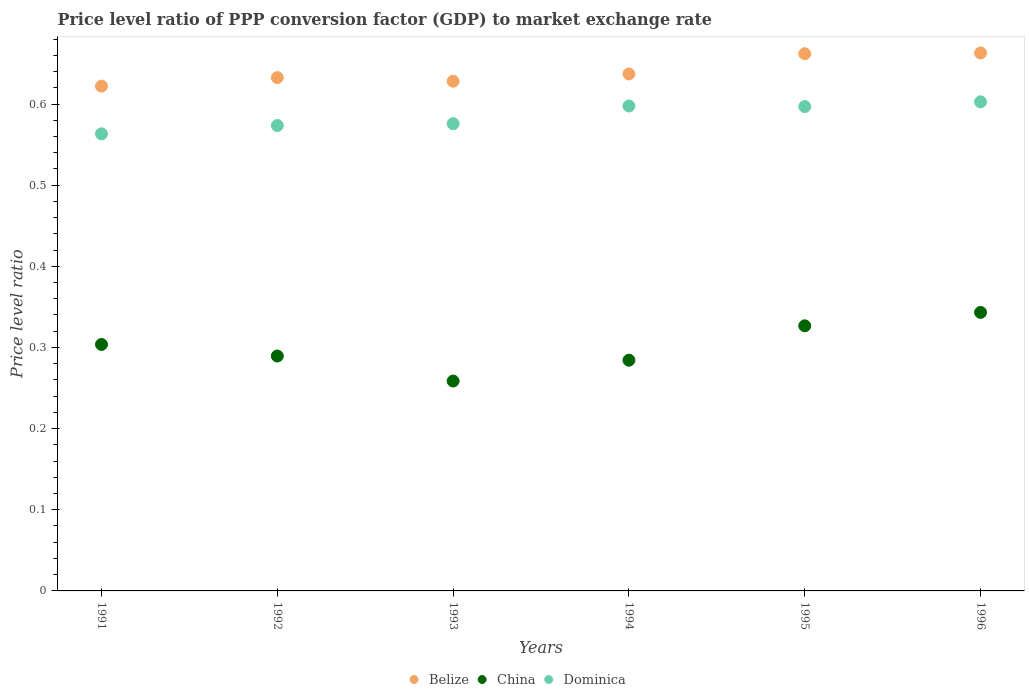How many different coloured dotlines are there?
Your response must be concise. 3. Is the number of dotlines equal to the number of legend labels?
Offer a terse response. Yes. What is the price level ratio in Belize in 1991?
Make the answer very short. 0.62. Across all years, what is the maximum price level ratio in Belize?
Make the answer very short. 0.66. Across all years, what is the minimum price level ratio in China?
Offer a terse response. 0.26. In which year was the price level ratio in Dominica maximum?
Give a very brief answer. 1996. What is the total price level ratio in Dominica in the graph?
Offer a very short reply. 3.51. What is the difference between the price level ratio in China in 1992 and that in 1993?
Keep it short and to the point. 0.03. What is the difference between the price level ratio in China in 1995 and the price level ratio in Dominica in 1996?
Offer a very short reply. -0.28. What is the average price level ratio in China per year?
Ensure brevity in your answer.  0.3. In the year 1992, what is the difference between the price level ratio in Belize and price level ratio in China?
Your answer should be compact. 0.34. What is the ratio of the price level ratio in China in 1991 to that in 1993?
Give a very brief answer. 1.17. Is the price level ratio in Dominica in 1991 less than that in 1994?
Make the answer very short. Yes. Is the difference between the price level ratio in Belize in 1991 and 1992 greater than the difference between the price level ratio in China in 1991 and 1992?
Your answer should be compact. No. What is the difference between the highest and the second highest price level ratio in China?
Ensure brevity in your answer.  0.02. What is the difference between the highest and the lowest price level ratio in Dominica?
Keep it short and to the point. 0.04. In how many years, is the price level ratio in China greater than the average price level ratio in China taken over all years?
Your response must be concise. 3. Is the sum of the price level ratio in Belize in 1991 and 1996 greater than the maximum price level ratio in China across all years?
Make the answer very short. Yes. Does the price level ratio in Belize monotonically increase over the years?
Keep it short and to the point. No. Is the price level ratio in Belize strictly greater than the price level ratio in Dominica over the years?
Provide a succinct answer. Yes. What is the difference between two consecutive major ticks on the Y-axis?
Your answer should be very brief. 0.1. Are the values on the major ticks of Y-axis written in scientific E-notation?
Keep it short and to the point. No. How many legend labels are there?
Your response must be concise. 3. What is the title of the graph?
Your answer should be compact. Price level ratio of PPP conversion factor (GDP) to market exchange rate. What is the label or title of the X-axis?
Keep it short and to the point. Years. What is the label or title of the Y-axis?
Provide a succinct answer. Price level ratio. What is the Price level ratio of Belize in 1991?
Your answer should be compact. 0.62. What is the Price level ratio in China in 1991?
Offer a terse response. 0.3. What is the Price level ratio of Dominica in 1991?
Give a very brief answer. 0.56. What is the Price level ratio of Belize in 1992?
Your response must be concise. 0.63. What is the Price level ratio in China in 1992?
Your answer should be very brief. 0.29. What is the Price level ratio in Dominica in 1992?
Provide a short and direct response. 0.57. What is the Price level ratio in Belize in 1993?
Ensure brevity in your answer.  0.63. What is the Price level ratio of China in 1993?
Your answer should be compact. 0.26. What is the Price level ratio of Dominica in 1993?
Give a very brief answer. 0.58. What is the Price level ratio in Belize in 1994?
Offer a very short reply. 0.64. What is the Price level ratio of China in 1994?
Keep it short and to the point. 0.28. What is the Price level ratio in Dominica in 1994?
Your answer should be compact. 0.6. What is the Price level ratio in Belize in 1995?
Offer a terse response. 0.66. What is the Price level ratio in China in 1995?
Provide a short and direct response. 0.33. What is the Price level ratio in Dominica in 1995?
Offer a very short reply. 0.6. What is the Price level ratio in Belize in 1996?
Offer a very short reply. 0.66. What is the Price level ratio in China in 1996?
Offer a very short reply. 0.34. What is the Price level ratio of Dominica in 1996?
Make the answer very short. 0.6. Across all years, what is the maximum Price level ratio in Belize?
Ensure brevity in your answer.  0.66. Across all years, what is the maximum Price level ratio of China?
Offer a very short reply. 0.34. Across all years, what is the maximum Price level ratio of Dominica?
Your response must be concise. 0.6. Across all years, what is the minimum Price level ratio of Belize?
Offer a very short reply. 0.62. Across all years, what is the minimum Price level ratio of China?
Provide a succinct answer. 0.26. Across all years, what is the minimum Price level ratio of Dominica?
Provide a succinct answer. 0.56. What is the total Price level ratio of Belize in the graph?
Give a very brief answer. 3.84. What is the total Price level ratio in China in the graph?
Provide a short and direct response. 1.81. What is the total Price level ratio in Dominica in the graph?
Your answer should be compact. 3.51. What is the difference between the Price level ratio of Belize in 1991 and that in 1992?
Keep it short and to the point. -0.01. What is the difference between the Price level ratio in China in 1991 and that in 1992?
Keep it short and to the point. 0.01. What is the difference between the Price level ratio in Dominica in 1991 and that in 1992?
Provide a short and direct response. -0.01. What is the difference between the Price level ratio of Belize in 1991 and that in 1993?
Provide a short and direct response. -0.01. What is the difference between the Price level ratio in China in 1991 and that in 1993?
Make the answer very short. 0.05. What is the difference between the Price level ratio in Dominica in 1991 and that in 1993?
Your response must be concise. -0.01. What is the difference between the Price level ratio in Belize in 1991 and that in 1994?
Offer a very short reply. -0.01. What is the difference between the Price level ratio in China in 1991 and that in 1994?
Provide a succinct answer. 0.02. What is the difference between the Price level ratio of Dominica in 1991 and that in 1994?
Your answer should be very brief. -0.03. What is the difference between the Price level ratio in Belize in 1991 and that in 1995?
Make the answer very short. -0.04. What is the difference between the Price level ratio of China in 1991 and that in 1995?
Keep it short and to the point. -0.02. What is the difference between the Price level ratio in Dominica in 1991 and that in 1995?
Ensure brevity in your answer.  -0.03. What is the difference between the Price level ratio of Belize in 1991 and that in 1996?
Provide a succinct answer. -0.04. What is the difference between the Price level ratio in China in 1991 and that in 1996?
Your answer should be compact. -0.04. What is the difference between the Price level ratio of Dominica in 1991 and that in 1996?
Your answer should be very brief. -0.04. What is the difference between the Price level ratio of Belize in 1992 and that in 1993?
Give a very brief answer. 0. What is the difference between the Price level ratio of China in 1992 and that in 1993?
Your response must be concise. 0.03. What is the difference between the Price level ratio in Dominica in 1992 and that in 1993?
Your response must be concise. -0. What is the difference between the Price level ratio in Belize in 1992 and that in 1994?
Provide a succinct answer. -0. What is the difference between the Price level ratio in China in 1992 and that in 1994?
Give a very brief answer. 0.01. What is the difference between the Price level ratio of Dominica in 1992 and that in 1994?
Provide a short and direct response. -0.02. What is the difference between the Price level ratio in Belize in 1992 and that in 1995?
Give a very brief answer. -0.03. What is the difference between the Price level ratio of China in 1992 and that in 1995?
Your response must be concise. -0.04. What is the difference between the Price level ratio of Dominica in 1992 and that in 1995?
Your answer should be very brief. -0.02. What is the difference between the Price level ratio of Belize in 1992 and that in 1996?
Your answer should be compact. -0.03. What is the difference between the Price level ratio of China in 1992 and that in 1996?
Keep it short and to the point. -0.05. What is the difference between the Price level ratio of Dominica in 1992 and that in 1996?
Your answer should be very brief. -0.03. What is the difference between the Price level ratio in Belize in 1993 and that in 1994?
Ensure brevity in your answer.  -0.01. What is the difference between the Price level ratio of China in 1993 and that in 1994?
Offer a very short reply. -0.03. What is the difference between the Price level ratio of Dominica in 1993 and that in 1994?
Your answer should be very brief. -0.02. What is the difference between the Price level ratio in Belize in 1993 and that in 1995?
Your answer should be compact. -0.03. What is the difference between the Price level ratio of China in 1993 and that in 1995?
Offer a very short reply. -0.07. What is the difference between the Price level ratio in Dominica in 1993 and that in 1995?
Your response must be concise. -0.02. What is the difference between the Price level ratio of Belize in 1993 and that in 1996?
Ensure brevity in your answer.  -0.03. What is the difference between the Price level ratio in China in 1993 and that in 1996?
Offer a terse response. -0.08. What is the difference between the Price level ratio in Dominica in 1993 and that in 1996?
Provide a short and direct response. -0.03. What is the difference between the Price level ratio in Belize in 1994 and that in 1995?
Offer a very short reply. -0.02. What is the difference between the Price level ratio of China in 1994 and that in 1995?
Your answer should be very brief. -0.04. What is the difference between the Price level ratio of Dominica in 1994 and that in 1995?
Your answer should be very brief. 0. What is the difference between the Price level ratio of Belize in 1994 and that in 1996?
Keep it short and to the point. -0.03. What is the difference between the Price level ratio in China in 1994 and that in 1996?
Offer a very short reply. -0.06. What is the difference between the Price level ratio of Dominica in 1994 and that in 1996?
Your answer should be very brief. -0.01. What is the difference between the Price level ratio in Belize in 1995 and that in 1996?
Make the answer very short. -0. What is the difference between the Price level ratio in China in 1995 and that in 1996?
Offer a very short reply. -0.02. What is the difference between the Price level ratio of Dominica in 1995 and that in 1996?
Make the answer very short. -0.01. What is the difference between the Price level ratio of Belize in 1991 and the Price level ratio of China in 1992?
Give a very brief answer. 0.33. What is the difference between the Price level ratio of Belize in 1991 and the Price level ratio of Dominica in 1992?
Your answer should be very brief. 0.05. What is the difference between the Price level ratio of China in 1991 and the Price level ratio of Dominica in 1992?
Your answer should be compact. -0.27. What is the difference between the Price level ratio in Belize in 1991 and the Price level ratio in China in 1993?
Make the answer very short. 0.36. What is the difference between the Price level ratio of Belize in 1991 and the Price level ratio of Dominica in 1993?
Your answer should be very brief. 0.05. What is the difference between the Price level ratio in China in 1991 and the Price level ratio in Dominica in 1993?
Offer a very short reply. -0.27. What is the difference between the Price level ratio in Belize in 1991 and the Price level ratio in China in 1994?
Offer a very short reply. 0.34. What is the difference between the Price level ratio of Belize in 1991 and the Price level ratio of Dominica in 1994?
Provide a succinct answer. 0.02. What is the difference between the Price level ratio in China in 1991 and the Price level ratio in Dominica in 1994?
Provide a short and direct response. -0.29. What is the difference between the Price level ratio in Belize in 1991 and the Price level ratio in China in 1995?
Offer a very short reply. 0.3. What is the difference between the Price level ratio of Belize in 1991 and the Price level ratio of Dominica in 1995?
Your answer should be very brief. 0.03. What is the difference between the Price level ratio in China in 1991 and the Price level ratio in Dominica in 1995?
Your response must be concise. -0.29. What is the difference between the Price level ratio of Belize in 1991 and the Price level ratio of China in 1996?
Offer a very short reply. 0.28. What is the difference between the Price level ratio of Belize in 1991 and the Price level ratio of Dominica in 1996?
Offer a very short reply. 0.02. What is the difference between the Price level ratio of China in 1991 and the Price level ratio of Dominica in 1996?
Your answer should be compact. -0.3. What is the difference between the Price level ratio in Belize in 1992 and the Price level ratio in China in 1993?
Offer a very short reply. 0.37. What is the difference between the Price level ratio in Belize in 1992 and the Price level ratio in Dominica in 1993?
Keep it short and to the point. 0.06. What is the difference between the Price level ratio of China in 1992 and the Price level ratio of Dominica in 1993?
Provide a succinct answer. -0.29. What is the difference between the Price level ratio in Belize in 1992 and the Price level ratio in China in 1994?
Offer a terse response. 0.35. What is the difference between the Price level ratio of Belize in 1992 and the Price level ratio of Dominica in 1994?
Offer a very short reply. 0.04. What is the difference between the Price level ratio in China in 1992 and the Price level ratio in Dominica in 1994?
Give a very brief answer. -0.31. What is the difference between the Price level ratio of Belize in 1992 and the Price level ratio of China in 1995?
Give a very brief answer. 0.31. What is the difference between the Price level ratio in Belize in 1992 and the Price level ratio in Dominica in 1995?
Keep it short and to the point. 0.04. What is the difference between the Price level ratio of China in 1992 and the Price level ratio of Dominica in 1995?
Make the answer very short. -0.31. What is the difference between the Price level ratio in Belize in 1992 and the Price level ratio in China in 1996?
Your response must be concise. 0.29. What is the difference between the Price level ratio in Belize in 1992 and the Price level ratio in Dominica in 1996?
Offer a terse response. 0.03. What is the difference between the Price level ratio of China in 1992 and the Price level ratio of Dominica in 1996?
Make the answer very short. -0.31. What is the difference between the Price level ratio in Belize in 1993 and the Price level ratio in China in 1994?
Provide a succinct answer. 0.34. What is the difference between the Price level ratio of Belize in 1993 and the Price level ratio of Dominica in 1994?
Your answer should be compact. 0.03. What is the difference between the Price level ratio of China in 1993 and the Price level ratio of Dominica in 1994?
Your answer should be very brief. -0.34. What is the difference between the Price level ratio in Belize in 1993 and the Price level ratio in China in 1995?
Give a very brief answer. 0.3. What is the difference between the Price level ratio in Belize in 1993 and the Price level ratio in Dominica in 1995?
Give a very brief answer. 0.03. What is the difference between the Price level ratio in China in 1993 and the Price level ratio in Dominica in 1995?
Offer a terse response. -0.34. What is the difference between the Price level ratio of Belize in 1993 and the Price level ratio of China in 1996?
Provide a succinct answer. 0.28. What is the difference between the Price level ratio in Belize in 1993 and the Price level ratio in Dominica in 1996?
Offer a terse response. 0.03. What is the difference between the Price level ratio in China in 1993 and the Price level ratio in Dominica in 1996?
Give a very brief answer. -0.34. What is the difference between the Price level ratio of Belize in 1994 and the Price level ratio of China in 1995?
Make the answer very short. 0.31. What is the difference between the Price level ratio in Belize in 1994 and the Price level ratio in Dominica in 1995?
Provide a succinct answer. 0.04. What is the difference between the Price level ratio of China in 1994 and the Price level ratio of Dominica in 1995?
Offer a terse response. -0.31. What is the difference between the Price level ratio in Belize in 1994 and the Price level ratio in China in 1996?
Provide a succinct answer. 0.29. What is the difference between the Price level ratio of Belize in 1994 and the Price level ratio of Dominica in 1996?
Make the answer very short. 0.03. What is the difference between the Price level ratio of China in 1994 and the Price level ratio of Dominica in 1996?
Your answer should be very brief. -0.32. What is the difference between the Price level ratio of Belize in 1995 and the Price level ratio of China in 1996?
Provide a short and direct response. 0.32. What is the difference between the Price level ratio in Belize in 1995 and the Price level ratio in Dominica in 1996?
Provide a short and direct response. 0.06. What is the difference between the Price level ratio of China in 1995 and the Price level ratio of Dominica in 1996?
Provide a short and direct response. -0.28. What is the average Price level ratio of Belize per year?
Make the answer very short. 0.64. What is the average Price level ratio of China per year?
Your answer should be very brief. 0.3. What is the average Price level ratio of Dominica per year?
Offer a very short reply. 0.58. In the year 1991, what is the difference between the Price level ratio in Belize and Price level ratio in China?
Offer a very short reply. 0.32. In the year 1991, what is the difference between the Price level ratio of Belize and Price level ratio of Dominica?
Provide a short and direct response. 0.06. In the year 1991, what is the difference between the Price level ratio of China and Price level ratio of Dominica?
Ensure brevity in your answer.  -0.26. In the year 1992, what is the difference between the Price level ratio of Belize and Price level ratio of China?
Provide a short and direct response. 0.34. In the year 1992, what is the difference between the Price level ratio of Belize and Price level ratio of Dominica?
Your answer should be very brief. 0.06. In the year 1992, what is the difference between the Price level ratio of China and Price level ratio of Dominica?
Ensure brevity in your answer.  -0.28. In the year 1993, what is the difference between the Price level ratio of Belize and Price level ratio of China?
Offer a terse response. 0.37. In the year 1993, what is the difference between the Price level ratio of Belize and Price level ratio of Dominica?
Keep it short and to the point. 0.05. In the year 1993, what is the difference between the Price level ratio in China and Price level ratio in Dominica?
Your response must be concise. -0.32. In the year 1994, what is the difference between the Price level ratio in Belize and Price level ratio in China?
Your answer should be compact. 0.35. In the year 1994, what is the difference between the Price level ratio of Belize and Price level ratio of Dominica?
Keep it short and to the point. 0.04. In the year 1994, what is the difference between the Price level ratio in China and Price level ratio in Dominica?
Provide a succinct answer. -0.31. In the year 1995, what is the difference between the Price level ratio in Belize and Price level ratio in China?
Your response must be concise. 0.34. In the year 1995, what is the difference between the Price level ratio in Belize and Price level ratio in Dominica?
Offer a very short reply. 0.07. In the year 1995, what is the difference between the Price level ratio in China and Price level ratio in Dominica?
Offer a terse response. -0.27. In the year 1996, what is the difference between the Price level ratio of Belize and Price level ratio of China?
Your response must be concise. 0.32. In the year 1996, what is the difference between the Price level ratio of Belize and Price level ratio of Dominica?
Offer a very short reply. 0.06. In the year 1996, what is the difference between the Price level ratio in China and Price level ratio in Dominica?
Offer a terse response. -0.26. What is the ratio of the Price level ratio in Belize in 1991 to that in 1992?
Your answer should be very brief. 0.98. What is the ratio of the Price level ratio of China in 1991 to that in 1992?
Provide a short and direct response. 1.05. What is the ratio of the Price level ratio of Dominica in 1991 to that in 1992?
Give a very brief answer. 0.98. What is the ratio of the Price level ratio in China in 1991 to that in 1993?
Provide a short and direct response. 1.17. What is the ratio of the Price level ratio of Dominica in 1991 to that in 1993?
Offer a very short reply. 0.98. What is the ratio of the Price level ratio of Belize in 1991 to that in 1994?
Your response must be concise. 0.98. What is the ratio of the Price level ratio in China in 1991 to that in 1994?
Provide a short and direct response. 1.07. What is the ratio of the Price level ratio in Dominica in 1991 to that in 1994?
Give a very brief answer. 0.94. What is the ratio of the Price level ratio of Belize in 1991 to that in 1995?
Keep it short and to the point. 0.94. What is the ratio of the Price level ratio in China in 1991 to that in 1995?
Keep it short and to the point. 0.93. What is the ratio of the Price level ratio of Dominica in 1991 to that in 1995?
Your answer should be compact. 0.94. What is the ratio of the Price level ratio of Belize in 1991 to that in 1996?
Offer a terse response. 0.94. What is the ratio of the Price level ratio in China in 1991 to that in 1996?
Keep it short and to the point. 0.88. What is the ratio of the Price level ratio in Dominica in 1991 to that in 1996?
Give a very brief answer. 0.93. What is the ratio of the Price level ratio in Belize in 1992 to that in 1993?
Keep it short and to the point. 1.01. What is the ratio of the Price level ratio of China in 1992 to that in 1993?
Give a very brief answer. 1.12. What is the ratio of the Price level ratio of China in 1992 to that in 1994?
Offer a very short reply. 1.02. What is the ratio of the Price level ratio in Dominica in 1992 to that in 1994?
Offer a terse response. 0.96. What is the ratio of the Price level ratio in Belize in 1992 to that in 1995?
Provide a succinct answer. 0.96. What is the ratio of the Price level ratio in China in 1992 to that in 1995?
Make the answer very short. 0.89. What is the ratio of the Price level ratio in Dominica in 1992 to that in 1995?
Provide a short and direct response. 0.96. What is the ratio of the Price level ratio of Belize in 1992 to that in 1996?
Ensure brevity in your answer.  0.95. What is the ratio of the Price level ratio of China in 1992 to that in 1996?
Your answer should be very brief. 0.84. What is the ratio of the Price level ratio of Dominica in 1992 to that in 1996?
Keep it short and to the point. 0.95. What is the ratio of the Price level ratio of Belize in 1993 to that in 1994?
Your response must be concise. 0.99. What is the ratio of the Price level ratio of China in 1993 to that in 1994?
Offer a very short reply. 0.91. What is the ratio of the Price level ratio of Dominica in 1993 to that in 1994?
Keep it short and to the point. 0.96. What is the ratio of the Price level ratio of Belize in 1993 to that in 1995?
Ensure brevity in your answer.  0.95. What is the ratio of the Price level ratio of China in 1993 to that in 1995?
Keep it short and to the point. 0.79. What is the ratio of the Price level ratio in Dominica in 1993 to that in 1995?
Offer a terse response. 0.96. What is the ratio of the Price level ratio in Belize in 1993 to that in 1996?
Ensure brevity in your answer.  0.95. What is the ratio of the Price level ratio in China in 1993 to that in 1996?
Make the answer very short. 0.75. What is the ratio of the Price level ratio in Dominica in 1993 to that in 1996?
Provide a succinct answer. 0.96. What is the ratio of the Price level ratio in Belize in 1994 to that in 1995?
Ensure brevity in your answer.  0.96. What is the ratio of the Price level ratio of China in 1994 to that in 1995?
Your response must be concise. 0.87. What is the ratio of the Price level ratio in Dominica in 1994 to that in 1995?
Your answer should be very brief. 1. What is the ratio of the Price level ratio in Belize in 1994 to that in 1996?
Give a very brief answer. 0.96. What is the ratio of the Price level ratio of China in 1994 to that in 1996?
Provide a short and direct response. 0.83. What is the ratio of the Price level ratio of Belize in 1995 to that in 1996?
Your answer should be compact. 1. What is the ratio of the Price level ratio in China in 1995 to that in 1996?
Keep it short and to the point. 0.95. What is the ratio of the Price level ratio of Dominica in 1995 to that in 1996?
Your answer should be very brief. 0.99. What is the difference between the highest and the second highest Price level ratio of Belize?
Provide a succinct answer. 0. What is the difference between the highest and the second highest Price level ratio in China?
Provide a short and direct response. 0.02. What is the difference between the highest and the second highest Price level ratio in Dominica?
Your answer should be very brief. 0.01. What is the difference between the highest and the lowest Price level ratio in Belize?
Provide a succinct answer. 0.04. What is the difference between the highest and the lowest Price level ratio in China?
Your answer should be compact. 0.08. What is the difference between the highest and the lowest Price level ratio of Dominica?
Offer a very short reply. 0.04. 